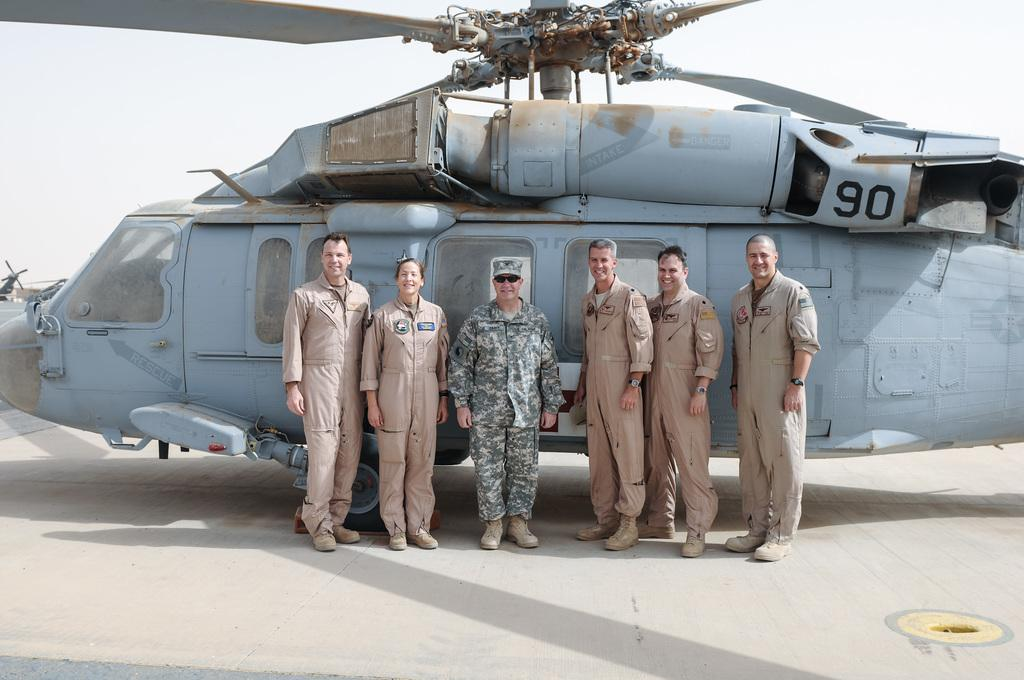How many people are in the image? There are six persons in the image. What is the position of the persons in the image? The persons are standing on the floor. What additional object can be seen in the image? There is a helicopter visible in the image. What type of basket is being used to crush the fowl in the image? There is no basket, crushing, or fowl present in the image. 